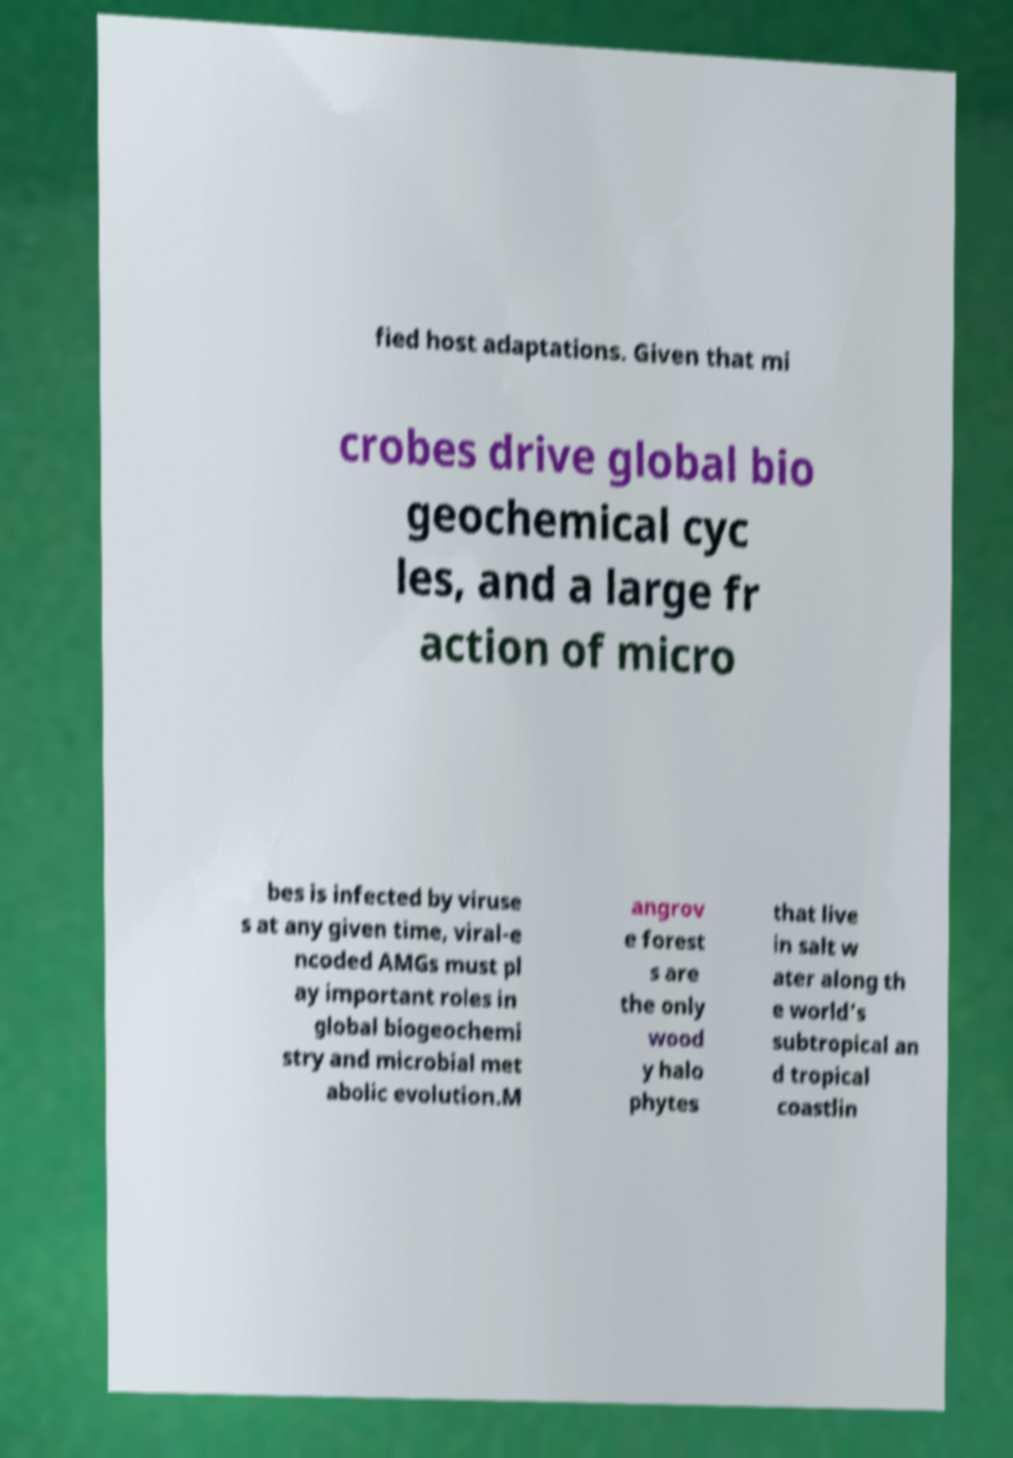Could you assist in decoding the text presented in this image and type it out clearly? fied host adaptations. Given that mi crobes drive global bio geochemical cyc les, and a large fr action of micro bes is infected by viruse s at any given time, viral-e ncoded AMGs must pl ay important roles in global biogeochemi stry and microbial met abolic evolution.M angrov e forest s are the only wood y halo phytes that live in salt w ater along th e world’s subtropical an d tropical coastlin 